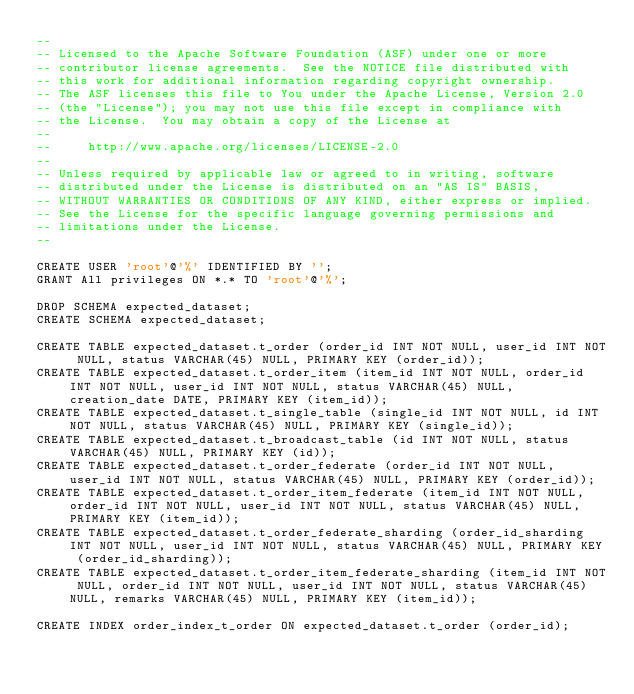<code> <loc_0><loc_0><loc_500><loc_500><_SQL_>--
-- Licensed to the Apache Software Foundation (ASF) under one or more
-- contributor license agreements.  See the NOTICE file distributed with
-- this work for additional information regarding copyright ownership.
-- The ASF licenses this file to You under the Apache License, Version 2.0
-- (the "License"); you may not use this file except in compliance with
-- the License.  You may obtain a copy of the License at
--
--     http://www.apache.org/licenses/LICENSE-2.0
--
-- Unless required by applicable law or agreed to in writing, software
-- distributed under the License is distributed on an "AS IS" BASIS,
-- WITHOUT WARRANTIES OR CONDITIONS OF ANY KIND, either express or implied.
-- See the License for the specific language governing permissions and
-- limitations under the License.
--

CREATE USER 'root'@'%' IDENTIFIED BY '';
GRANT All privileges ON *.* TO 'root'@'%';

DROP SCHEMA expected_dataset;
CREATE SCHEMA expected_dataset;

CREATE TABLE expected_dataset.t_order (order_id INT NOT NULL, user_id INT NOT NULL, status VARCHAR(45) NULL, PRIMARY KEY (order_id));
CREATE TABLE expected_dataset.t_order_item (item_id INT NOT NULL, order_id INT NOT NULL, user_id INT NOT NULL, status VARCHAR(45) NULL, creation_date DATE, PRIMARY KEY (item_id));
CREATE TABLE expected_dataset.t_single_table (single_id INT NOT NULL, id INT NOT NULL, status VARCHAR(45) NULL, PRIMARY KEY (single_id));
CREATE TABLE expected_dataset.t_broadcast_table (id INT NOT NULL, status VARCHAR(45) NULL, PRIMARY KEY (id));
CREATE TABLE expected_dataset.t_order_federate (order_id INT NOT NULL, user_id INT NOT NULL, status VARCHAR(45) NULL, PRIMARY KEY (order_id));
CREATE TABLE expected_dataset.t_order_item_federate (item_id INT NOT NULL, order_id INT NOT NULL, user_id INT NOT NULL, status VARCHAR(45) NULL, PRIMARY KEY (item_id));
CREATE TABLE expected_dataset.t_order_federate_sharding (order_id_sharding INT NOT NULL, user_id INT NOT NULL, status VARCHAR(45) NULL, PRIMARY KEY (order_id_sharding));
CREATE TABLE expected_dataset.t_order_item_federate_sharding (item_id INT NOT NULL, order_id INT NOT NULL, user_id INT NOT NULL, status VARCHAR(45) NULL, remarks VARCHAR(45) NULL, PRIMARY KEY (item_id));

CREATE INDEX order_index_t_order ON expected_dataset.t_order (order_id);
</code> 